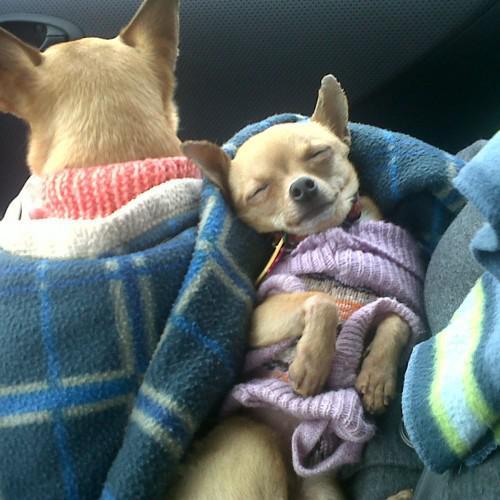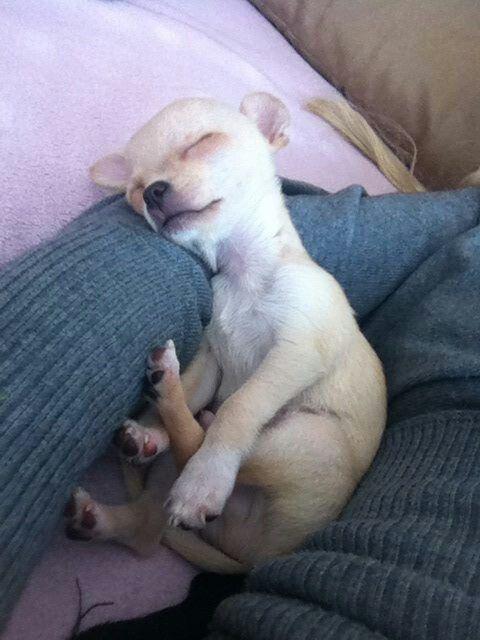The first image is the image on the left, the second image is the image on the right. For the images shown, is this caption "At least one chihuahua is sleeping on its back on a cozy blanket." true? Answer yes or no. Yes. The first image is the image on the left, the second image is the image on the right. Analyze the images presented: Is the assertion "The left image shows two chihuahuas in sleeping poses side-by-side, and the right image shows one snoozing chihuahua on solid-colored fabric." valid? Answer yes or no. Yes. 